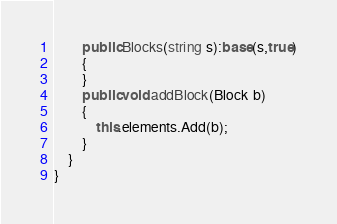Convert code to text. <code><loc_0><loc_0><loc_500><loc_500><_C#_>		public Blocks(string s):base(s,true)
		{
		}
		public void addBlock(Block b)
		{
			this.elements.Add(b);
		}
	}
}
</code> 